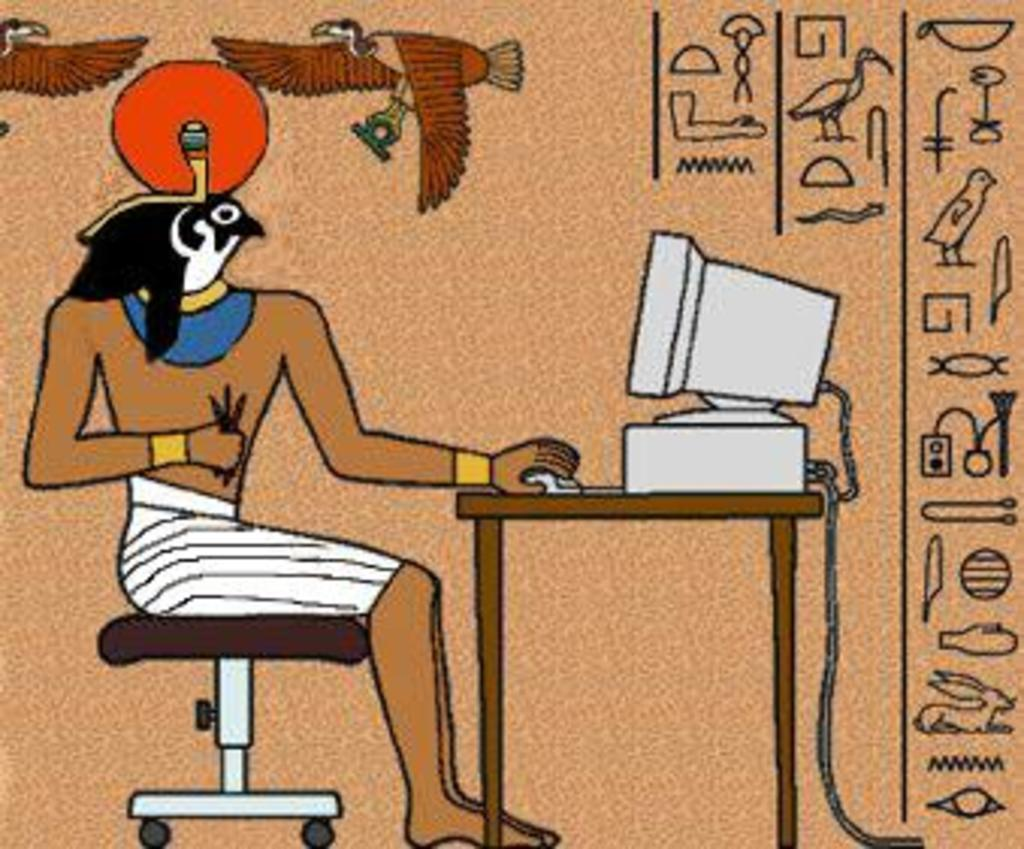What is the main subject of the sketch in the image? The sketch depicts a person. What is the person doing in the sketch? The person is sitting in front of a computer. Where is the computer placed in the sketch? The computer is placed on a table. What color is the background of the sketch? The background of the sketch is in cream color. What type of cheese can be seen melting on the slope in the image? There is no cheese or slope present in the image; it contains a sketch of a person sitting in front of a computer. 